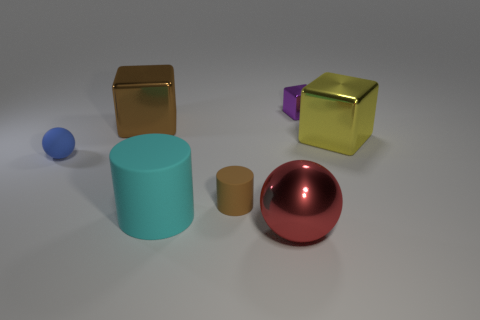The ball that is made of the same material as the cyan object is what color?
Provide a succinct answer. Blue. There is a thing to the right of the tiny thing behind the tiny blue object; what is its material?
Ensure brevity in your answer.  Metal. What number of objects are large balls in front of the tiny block or metal cubes that are left of the cyan cylinder?
Offer a very short reply. 2. What size is the brown thing in front of the thing that is to the left of the block on the left side of the red thing?
Your answer should be very brief. Small. Are there an equal number of tiny blue matte balls behind the purple metal cube and tiny red shiny cylinders?
Provide a short and direct response. Yes. Is the shape of the blue matte thing the same as the big metal thing that is in front of the blue sphere?
Make the answer very short. Yes. There is a cyan matte thing that is the same shape as the tiny brown matte thing; what is its size?
Your answer should be very brief. Large. How many other objects are there of the same material as the blue thing?
Make the answer very short. 2. What is the material of the large brown block?
Make the answer very short. Metal. There is a cylinder behind the large cyan rubber object; is its color the same as the large block behind the yellow metal cube?
Give a very brief answer. Yes. 